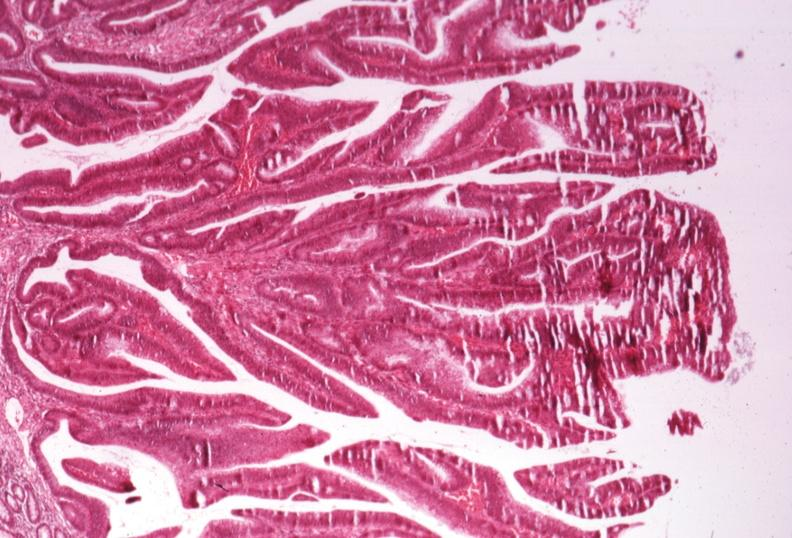what is present?
Answer the question using a single word or phrase. Villous adenoma 